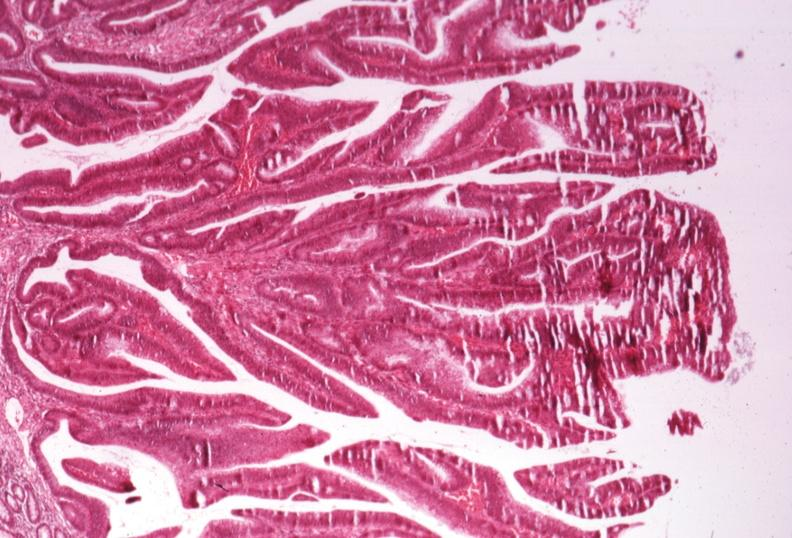what is present?
Answer the question using a single word or phrase. Villous adenoma 